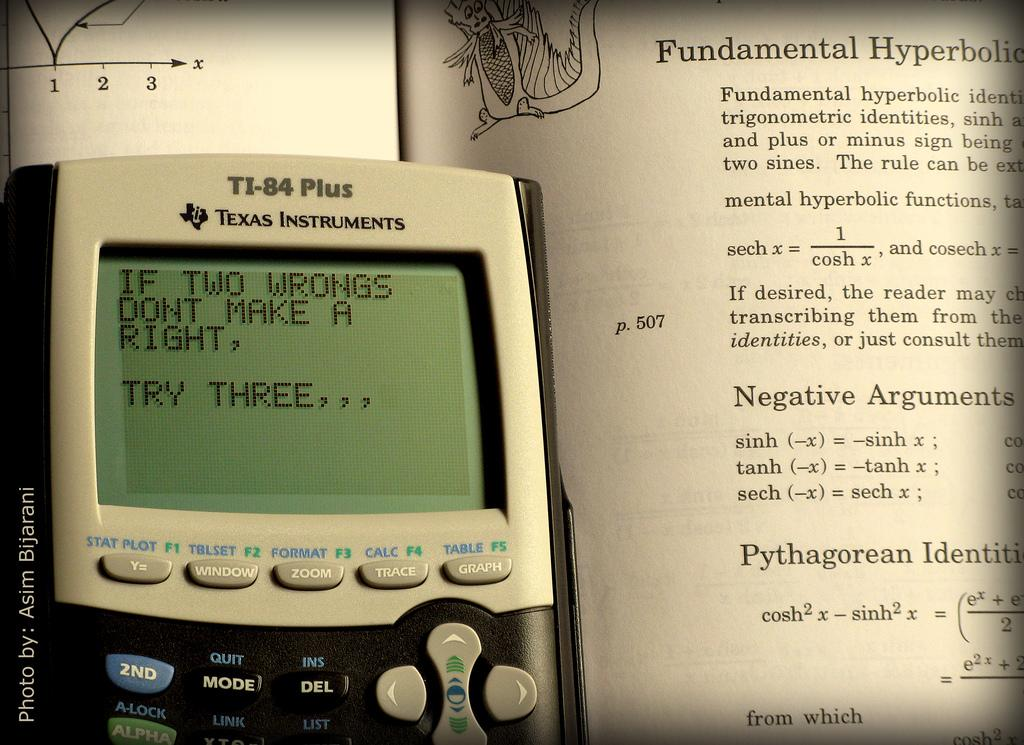<image>
Summarize the visual content of the image. ti-84 plus texas instruments  that says 'if two wrongs dont make a right, try three...' 